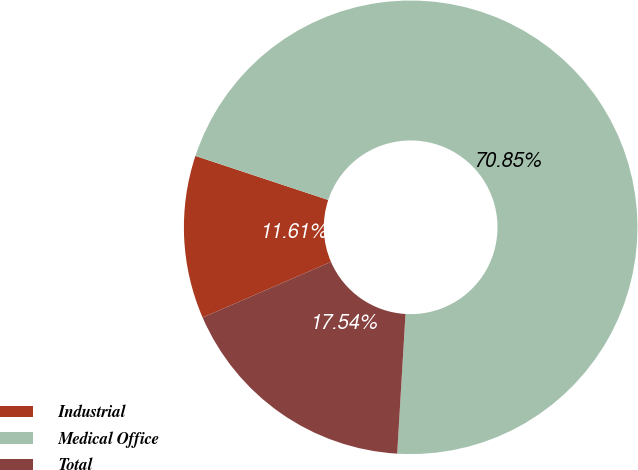Convert chart to OTSL. <chart><loc_0><loc_0><loc_500><loc_500><pie_chart><fcel>Industrial<fcel>Medical Office<fcel>Total<nl><fcel>11.61%<fcel>70.85%<fcel>17.54%<nl></chart> 